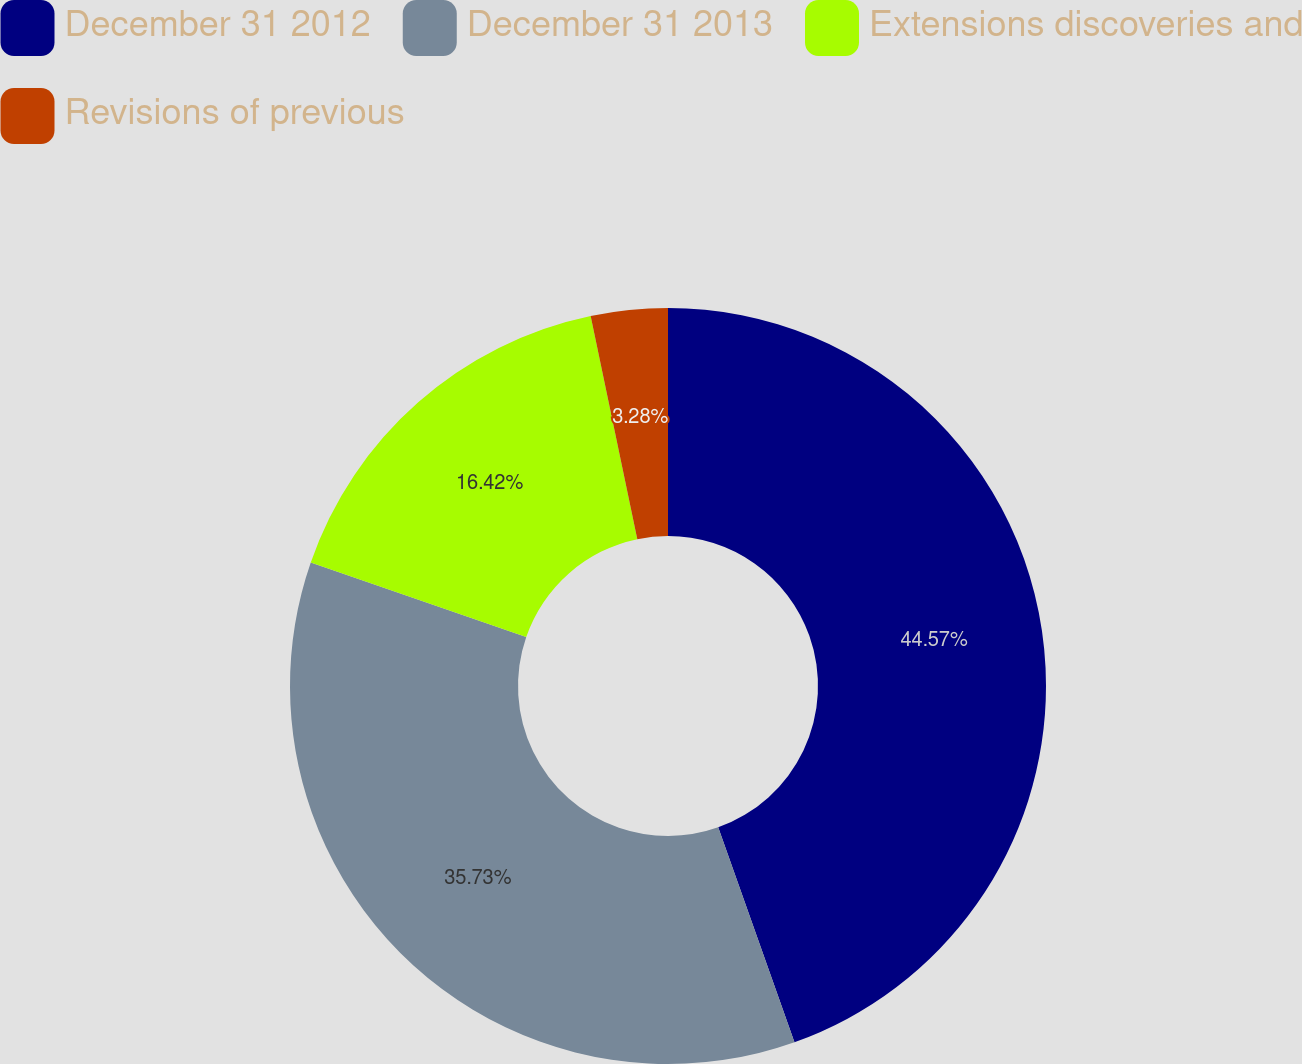Convert chart to OTSL. <chart><loc_0><loc_0><loc_500><loc_500><pie_chart><fcel>December 31 2012<fcel>December 31 2013<fcel>Extensions discoveries and<fcel>Revisions of previous<nl><fcel>44.57%<fcel>35.73%<fcel>16.42%<fcel>3.28%<nl></chart> 